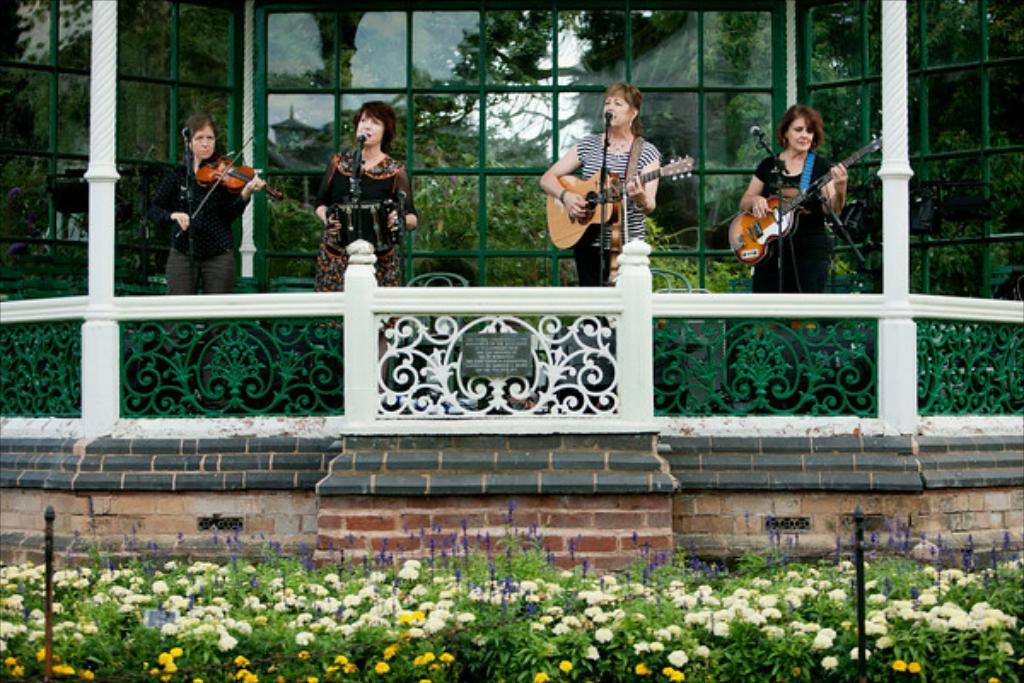Describe this image in one or two sentences. In this image i can see a group of women are playing musical instruments in front of a microphone. I can also see there are flower plants on the ground. 